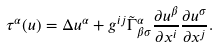Convert formula to latex. <formula><loc_0><loc_0><loc_500><loc_500>\tau ^ { \alpha } ( u ) = \Delta u ^ { \alpha } + g ^ { i j } \tilde { \Gamma } ^ { \alpha } _ { \beta \sigma } \frac { \partial u ^ { \beta } } { \partial x ^ { i } } \frac { \partial u ^ { \sigma } } { \partial x ^ { j } } .</formula> 